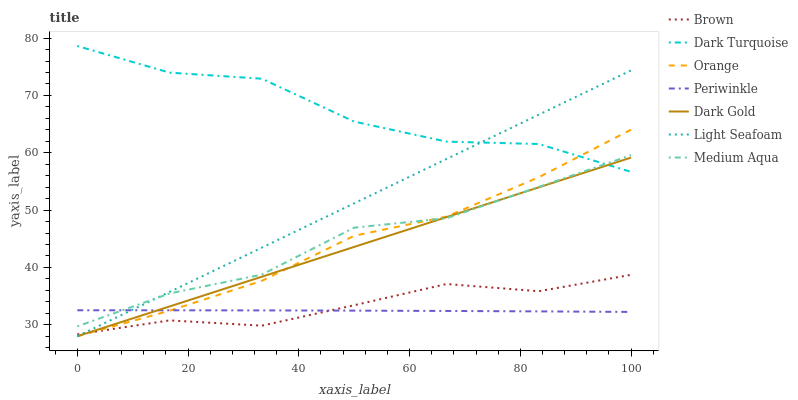Does Periwinkle have the minimum area under the curve?
Answer yes or no. Yes. Does Dark Turquoise have the maximum area under the curve?
Answer yes or no. Yes. Does Dark Gold have the minimum area under the curve?
Answer yes or no. No. Does Dark Gold have the maximum area under the curve?
Answer yes or no. No. Is Dark Gold the smoothest?
Answer yes or no. Yes. Is Dark Turquoise the roughest?
Answer yes or no. Yes. Is Dark Turquoise the smoothest?
Answer yes or no. No. Is Dark Gold the roughest?
Answer yes or no. No. Does Dark Gold have the lowest value?
Answer yes or no. Yes. Does Dark Turquoise have the lowest value?
Answer yes or no. No. Does Dark Turquoise have the highest value?
Answer yes or no. Yes. Does Dark Gold have the highest value?
Answer yes or no. No. Is Brown less than Medium Aqua?
Answer yes or no. Yes. Is Dark Turquoise greater than Brown?
Answer yes or no. Yes. Does Dark Turquoise intersect Medium Aqua?
Answer yes or no. Yes. Is Dark Turquoise less than Medium Aqua?
Answer yes or no. No. Is Dark Turquoise greater than Medium Aqua?
Answer yes or no. No. Does Brown intersect Medium Aqua?
Answer yes or no. No. 